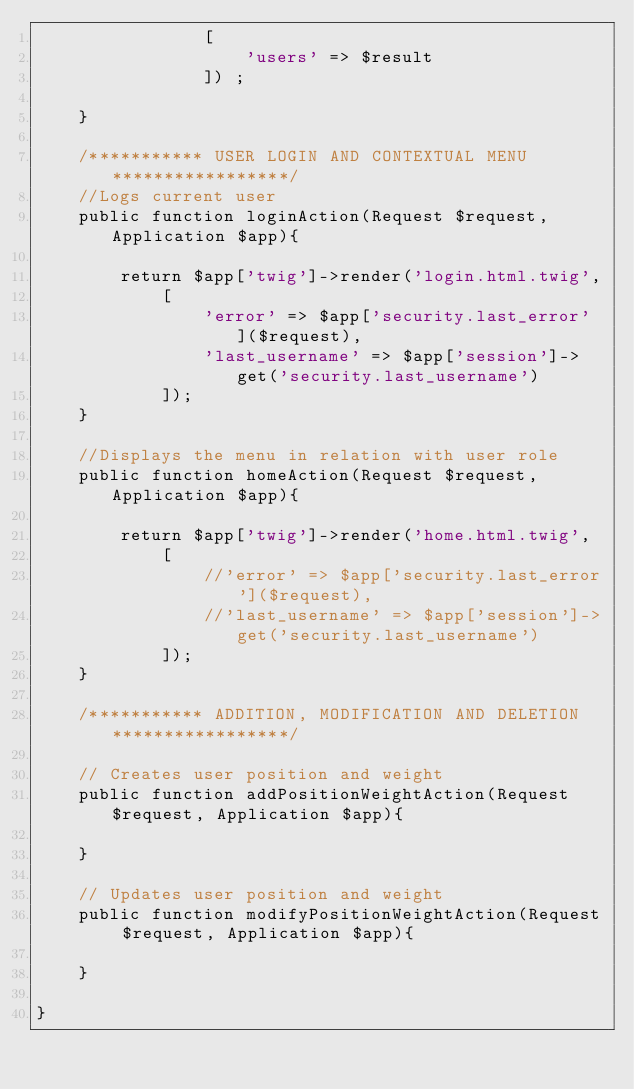<code> <loc_0><loc_0><loc_500><loc_500><_PHP_>                [
                    'users' => $result
                ]) ;

    }

    /*********** USER LOGIN AND CONTEXTUAL MENU *****************/
    //Logs current user
    public function loginAction(Request $request,Application $app){

        return $app['twig']->render('login.html.twig',
            [
                'error' => $app['security.last_error']($request),
                'last_username' => $app['session']->get('security.last_username')
            ]);
    }

    //Displays the menu in relation with user role
    public function homeAction(Request $request, Application $app){

        return $app['twig']->render('home.html.twig',
            [
                //'error' => $app['security.last_error']($request),
                //'last_username' => $app['session']->get('security.last_username')
            ]);
    }

    /*********** ADDITION, MODIFICATION AND DELETION *****************/

    // Creates user position and weight
    public function addPositionWeightAction(Request $request, Application $app){

    }

    // Updates user position and weight
    public function modifyPositionWeightAction(Request $request, Application $app){

    }

}
</code> 